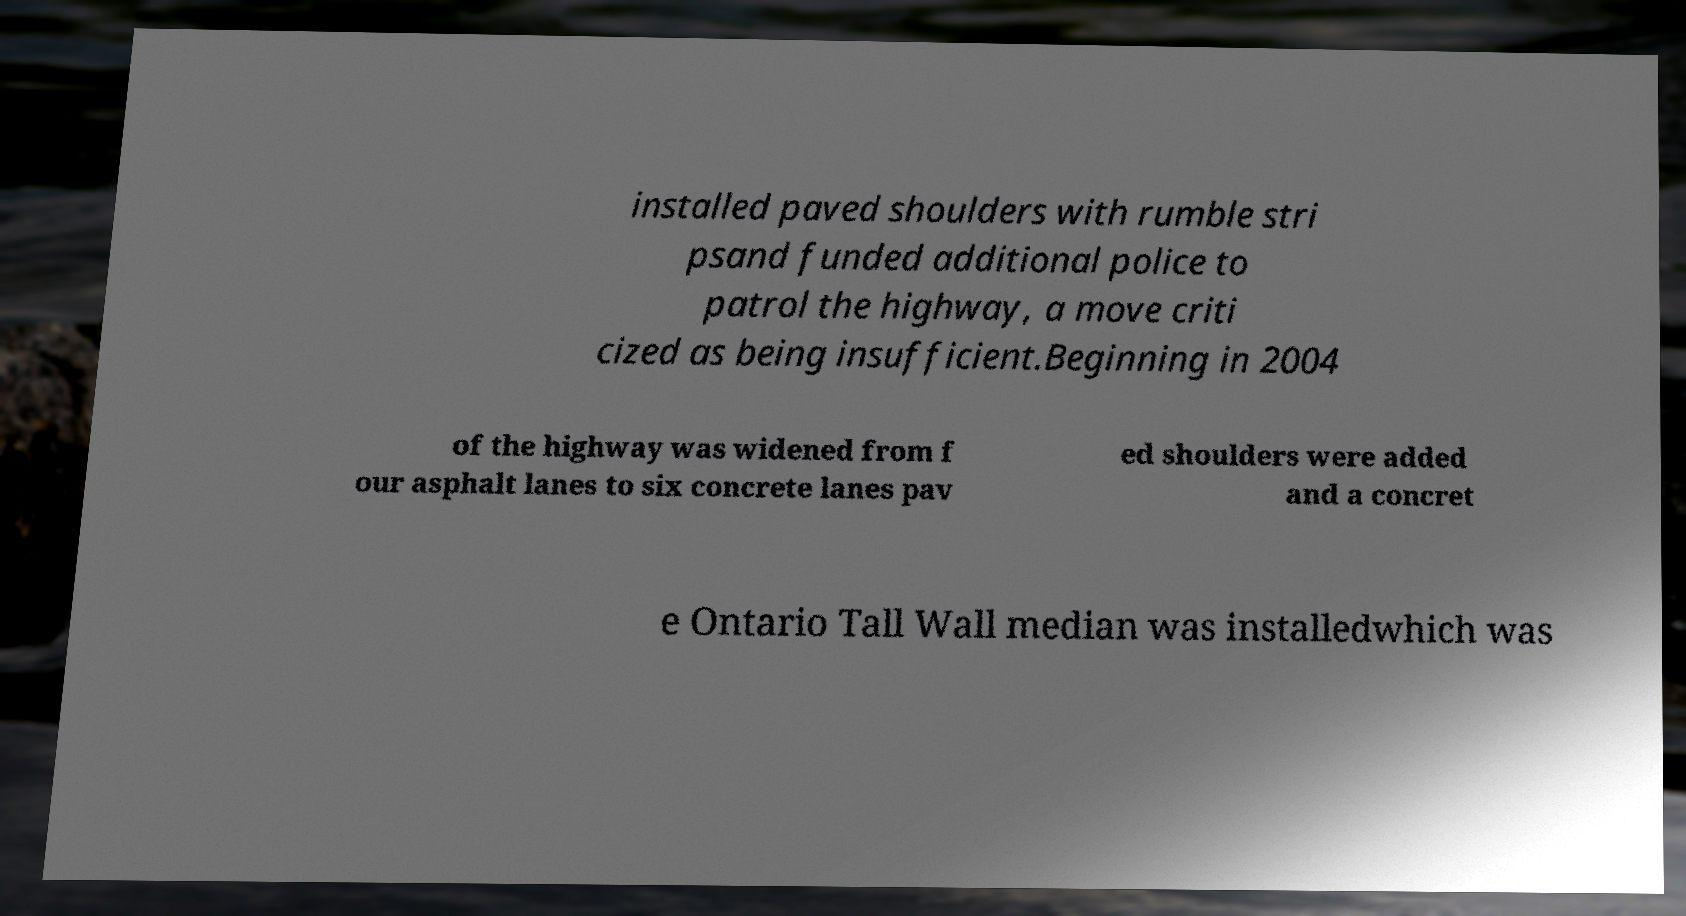I need the written content from this picture converted into text. Can you do that? installed paved shoulders with rumble stri psand funded additional police to patrol the highway, a move criti cized as being insufficient.Beginning in 2004 of the highway was widened from f our asphalt lanes to six concrete lanes pav ed shoulders were added and a concret e Ontario Tall Wall median was installedwhich was 